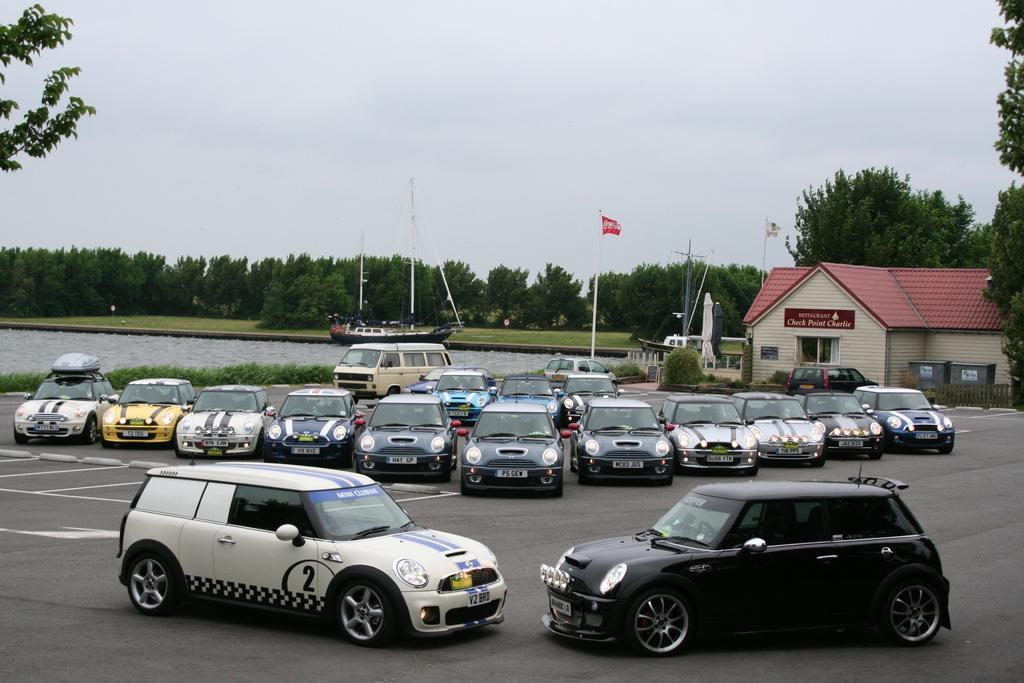Could you give a brief overview of what you see in this image? In this image we can see some vehicles on the road and on the left side of the image we can see a house and there are two flags. We can see two ships on the water and there are some trees and at the top we can see the sky. 